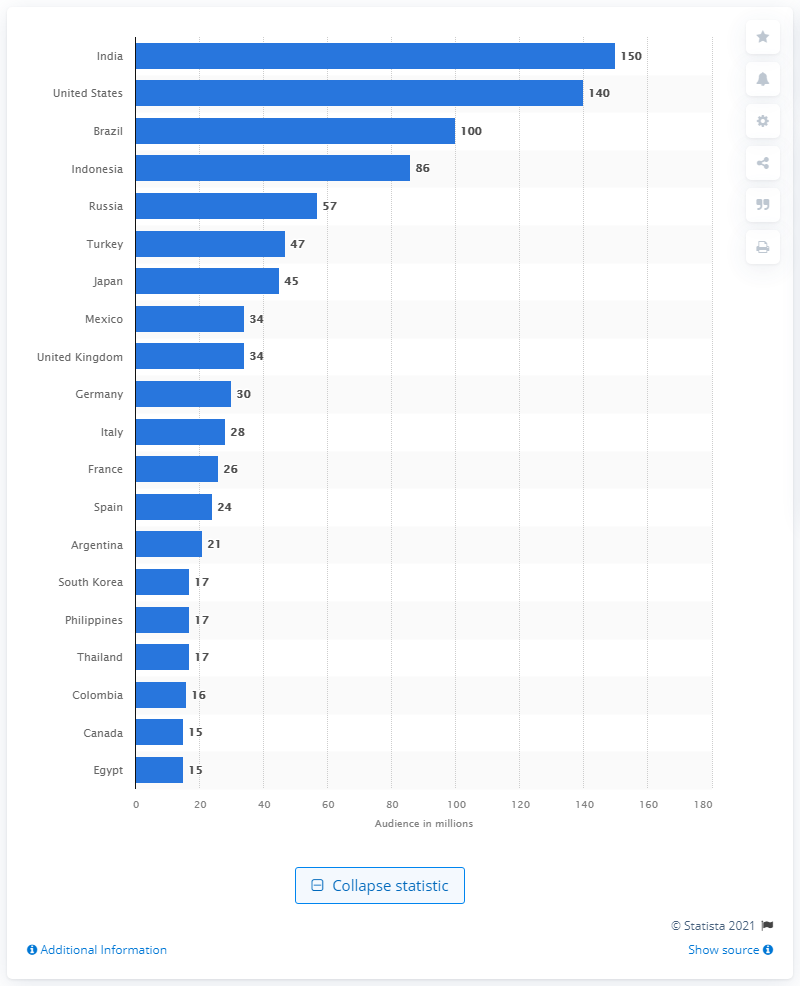Point out several critical features in this image. India has the largest number of Instagram users among all countries. Indonesia has the most Instagram users among all countries. 